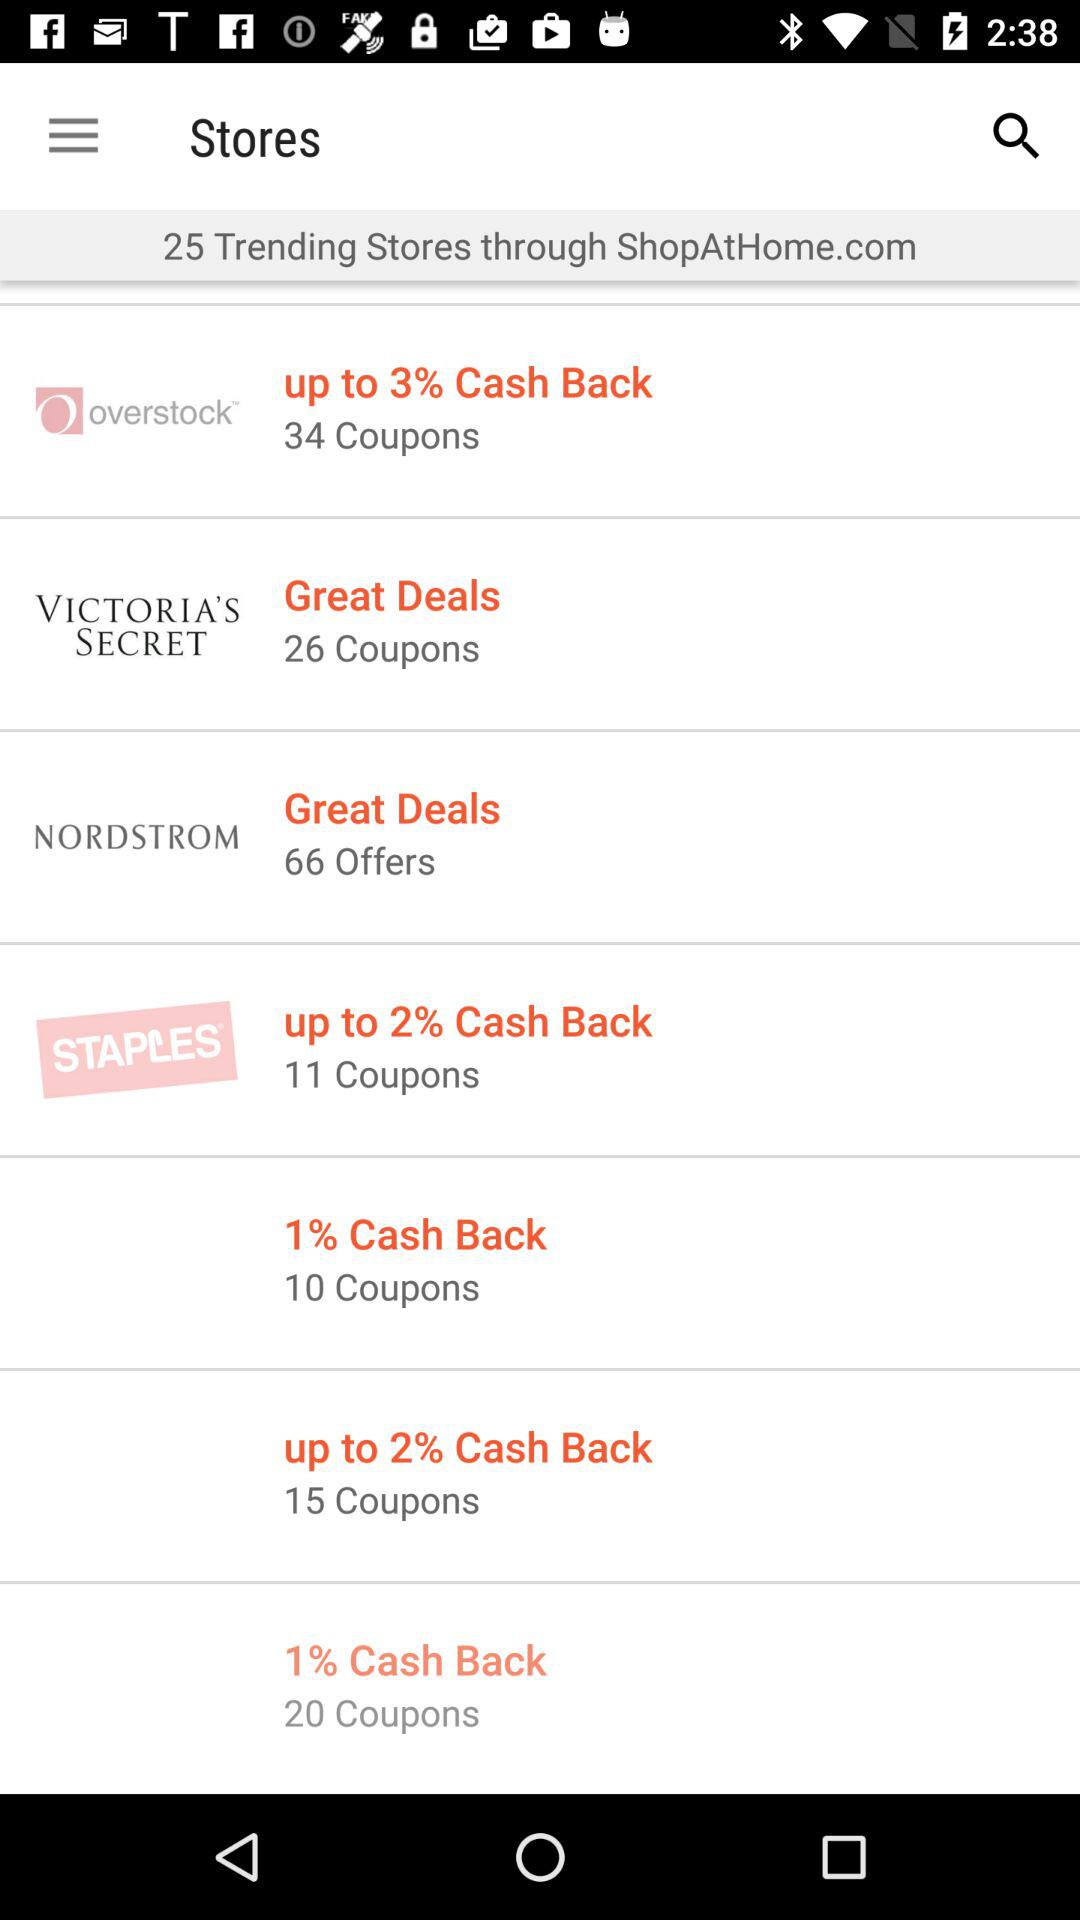Which store is offering 34 coupons? The store that is offering 34 coupons is "overstock". 